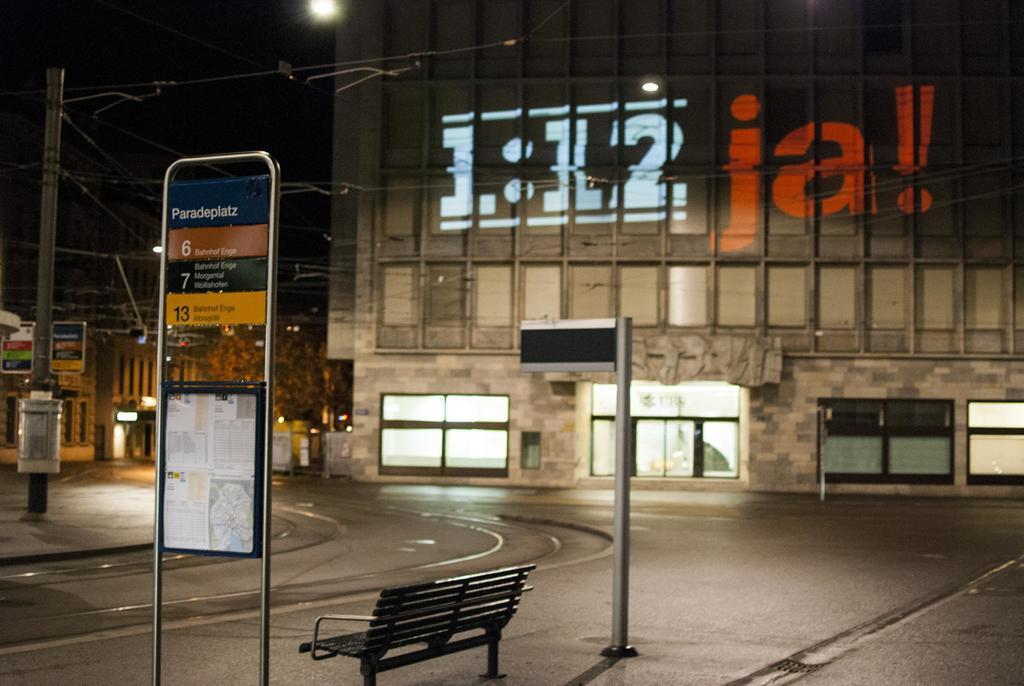Describe this image in one or two sentences. In this picture I can observe a road. There is a bench on the bottom of the picture. I can observe pole in the middle of the picture. On the left side there is another pole. In the background there is a building. On the left side there are some trees. The background is dark. 